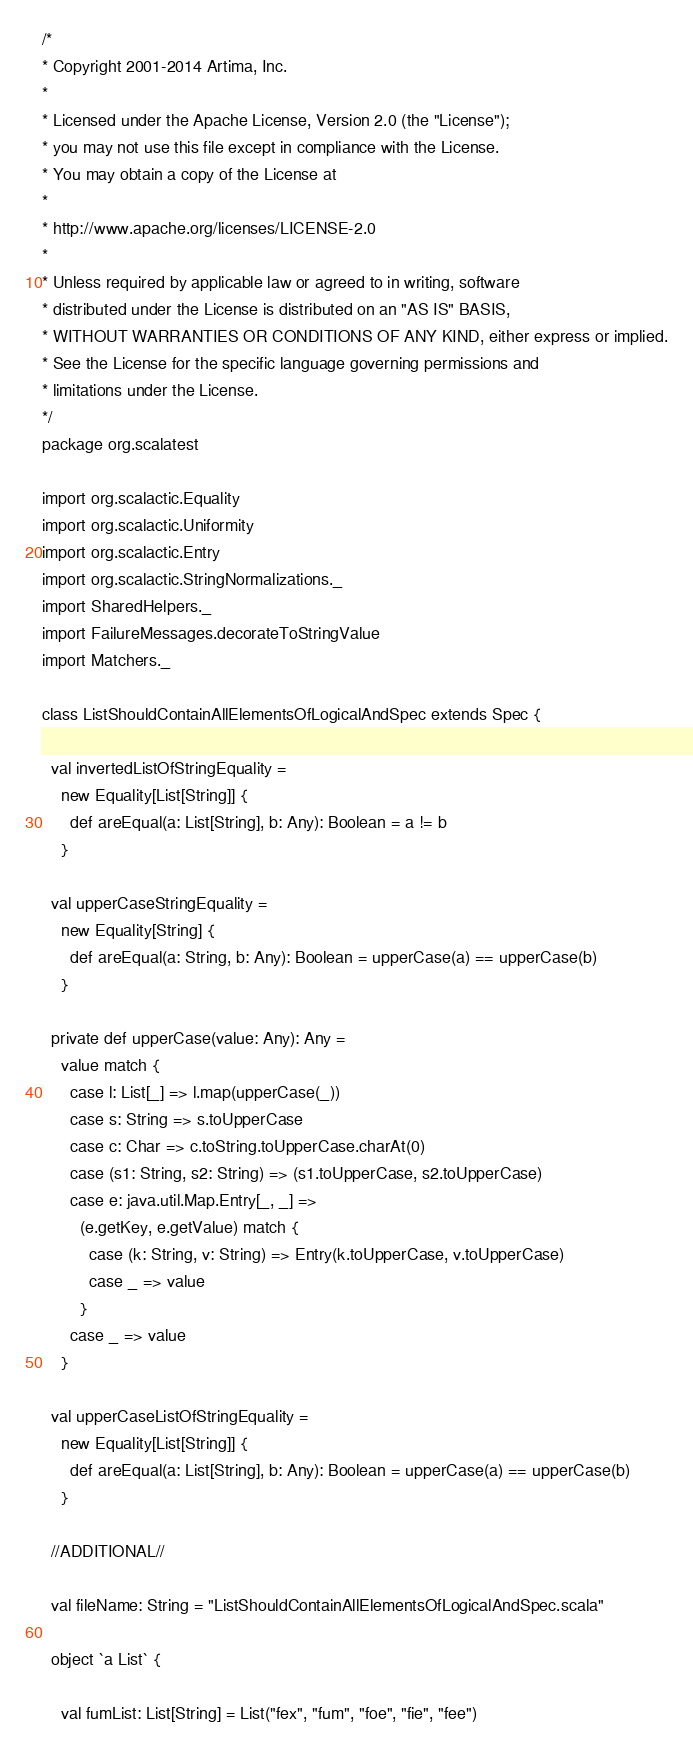<code> <loc_0><loc_0><loc_500><loc_500><_Scala_>/*
* Copyright 2001-2014 Artima, Inc.
*
* Licensed under the Apache License, Version 2.0 (the "License");
* you may not use this file except in compliance with the License.
* You may obtain a copy of the License at
*
* http://www.apache.org/licenses/LICENSE-2.0
*
* Unless required by applicable law or agreed to in writing, software
* distributed under the License is distributed on an "AS IS" BASIS,
* WITHOUT WARRANTIES OR CONDITIONS OF ANY KIND, either express or implied.
* See the License for the specific language governing permissions and
* limitations under the License.
*/
package org.scalatest

import org.scalactic.Equality
import org.scalactic.Uniformity
import org.scalactic.Entry
import org.scalactic.StringNormalizations._
import SharedHelpers._
import FailureMessages.decorateToStringValue
import Matchers._

class ListShouldContainAllElementsOfLogicalAndSpec extends Spec {

  val invertedListOfStringEquality =
    new Equality[List[String]] {
      def areEqual(a: List[String], b: Any): Boolean = a != b
    }

  val upperCaseStringEquality =
    new Equality[String] {
      def areEqual(a: String, b: Any): Boolean = upperCase(a) == upperCase(b)
    }

  private def upperCase(value: Any): Any =
    value match {
      case l: List[_] => l.map(upperCase(_))
      case s: String => s.toUpperCase
      case c: Char => c.toString.toUpperCase.charAt(0)
      case (s1: String, s2: String) => (s1.toUpperCase, s2.toUpperCase)
      case e: java.util.Map.Entry[_, _] =>
        (e.getKey, e.getValue) match {
          case (k: String, v: String) => Entry(k.toUpperCase, v.toUpperCase)
          case _ => value
        }
      case _ => value
    }

  val upperCaseListOfStringEquality =
    new Equality[List[String]] {
      def areEqual(a: List[String], b: Any): Boolean = upperCase(a) == upperCase(b)
    }

  //ADDITIONAL//

  val fileName: String = "ListShouldContainAllElementsOfLogicalAndSpec.scala"

  object `a List` {

    val fumList: List[String] = List("fex", "fum", "foe", "fie", "fee")</code> 